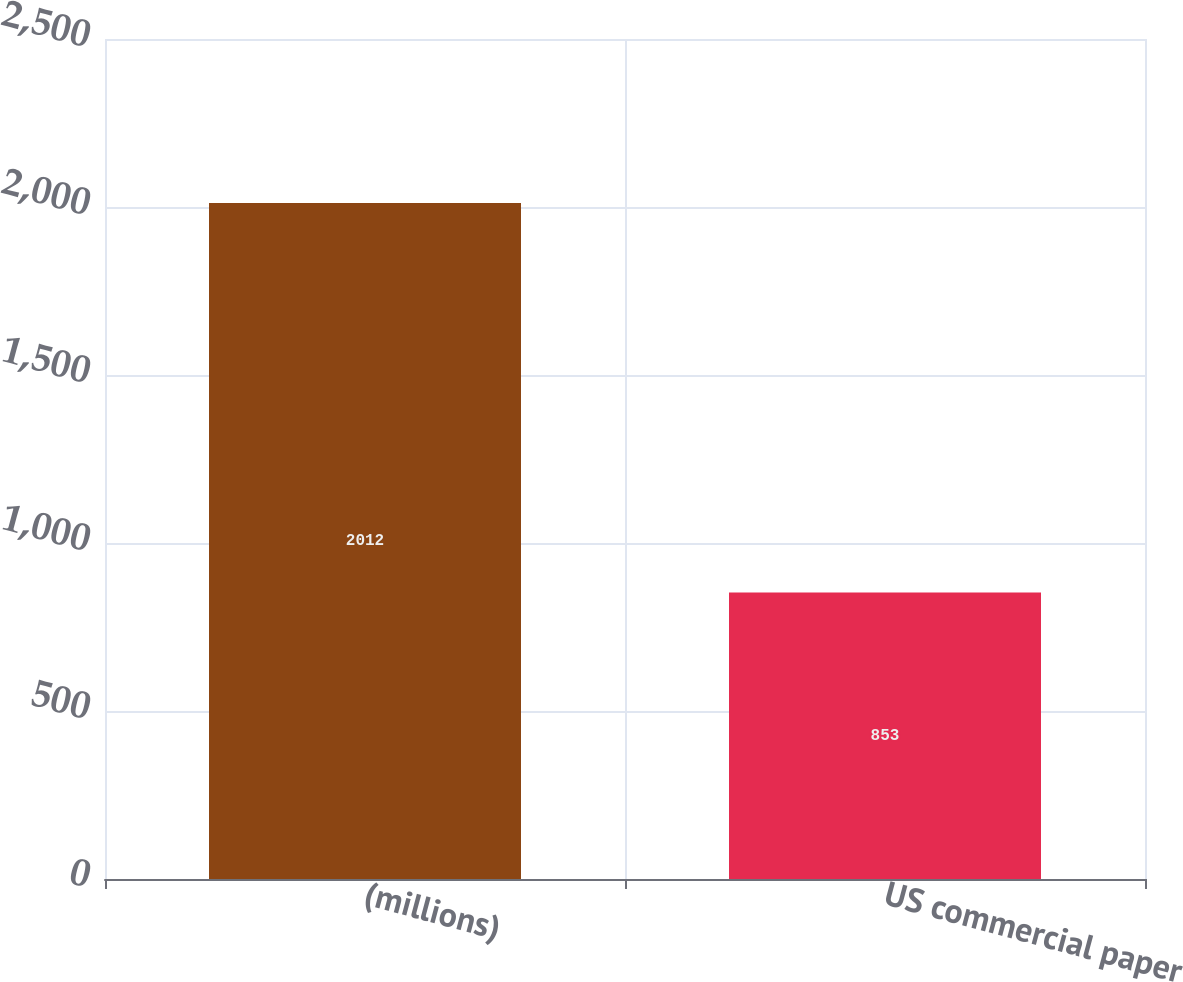Convert chart. <chart><loc_0><loc_0><loc_500><loc_500><bar_chart><fcel>(millions)<fcel>US commercial paper<nl><fcel>2012<fcel>853<nl></chart> 